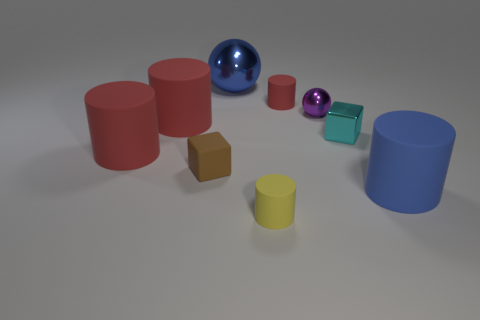Are there any rubber cylinders of the same color as the big metallic sphere?
Offer a very short reply. Yes. Does the small cyan metallic object have the same shape as the tiny object that is on the left side of the large blue shiny thing?
Provide a short and direct response. Yes. What number of other things are there of the same size as the blue metallic ball?
Provide a succinct answer. 3. What is the size of the brown rubber block that is on the left side of the small purple metallic sphere?
Keep it short and to the point. Small. What number of cyan cubes have the same material as the blue cylinder?
Give a very brief answer. 0. There is a blue object that is behind the tiny red rubber thing; does it have the same shape as the purple metallic object?
Provide a succinct answer. Yes. There is a big blue object that is behind the small brown object; what shape is it?
Your answer should be compact. Sphere. The cylinder that is the same color as the big metallic sphere is what size?
Give a very brief answer. Large. What material is the tiny brown cube?
Offer a very short reply. Rubber. What is the color of the metal cube that is the same size as the purple sphere?
Keep it short and to the point. Cyan. 